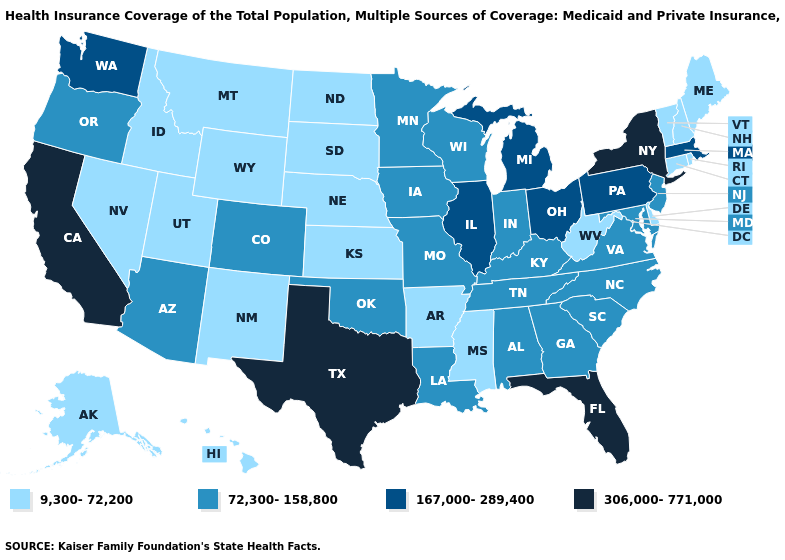What is the lowest value in states that border New Jersey?
Quick response, please. 9,300-72,200. Does the map have missing data?
Answer briefly. No. Does Massachusetts have the lowest value in the USA?
Be succinct. No. Name the states that have a value in the range 167,000-289,400?
Keep it brief. Illinois, Massachusetts, Michigan, Ohio, Pennsylvania, Washington. What is the lowest value in the MidWest?
Write a very short answer. 9,300-72,200. Name the states that have a value in the range 72,300-158,800?
Be succinct. Alabama, Arizona, Colorado, Georgia, Indiana, Iowa, Kentucky, Louisiana, Maryland, Minnesota, Missouri, New Jersey, North Carolina, Oklahoma, Oregon, South Carolina, Tennessee, Virginia, Wisconsin. Name the states that have a value in the range 306,000-771,000?
Short answer required. California, Florida, New York, Texas. What is the lowest value in states that border New Jersey?
Answer briefly. 9,300-72,200. What is the value of Minnesota?
Give a very brief answer. 72,300-158,800. Among the states that border Maryland , which have the lowest value?
Quick response, please. Delaware, West Virginia. Does Oklahoma have the same value as Kentucky?
Keep it brief. Yes. What is the value of South Carolina?
Keep it brief. 72,300-158,800. Does Florida have the highest value in the USA?
Quick response, please. Yes. Name the states that have a value in the range 167,000-289,400?
Short answer required. Illinois, Massachusetts, Michigan, Ohio, Pennsylvania, Washington. Is the legend a continuous bar?
Short answer required. No. 